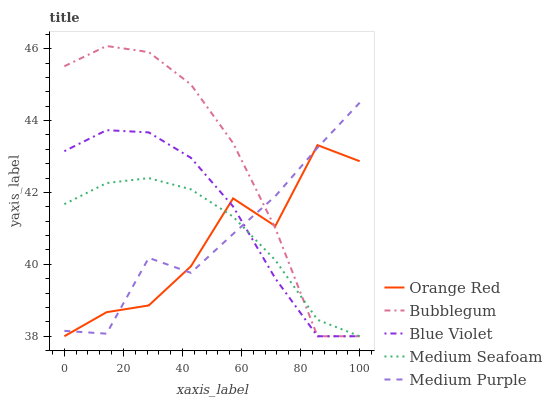Does Orange Red have the minimum area under the curve?
Answer yes or no. Yes. Does Bubblegum have the maximum area under the curve?
Answer yes or no. Yes. Does Medium Purple have the minimum area under the curve?
Answer yes or no. No. Does Medium Purple have the maximum area under the curve?
Answer yes or no. No. Is Medium Seafoam the smoothest?
Answer yes or no. Yes. Is Orange Red the roughest?
Answer yes or no. Yes. Is Medium Purple the smoothest?
Answer yes or no. No. Is Medium Purple the roughest?
Answer yes or no. No. Does Blue Violet have the lowest value?
Answer yes or no. Yes. Does Medium Purple have the lowest value?
Answer yes or no. No. Does Bubblegum have the highest value?
Answer yes or no. Yes. Does Medium Purple have the highest value?
Answer yes or no. No. Does Medium Purple intersect Orange Red?
Answer yes or no. Yes. Is Medium Purple less than Orange Red?
Answer yes or no. No. Is Medium Purple greater than Orange Red?
Answer yes or no. No. 